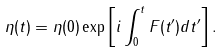Convert formula to latex. <formula><loc_0><loc_0><loc_500><loc_500>\eta ( t ) = \eta ( 0 ) \exp \left [ i \int _ { 0 } ^ { t } F ( t ^ { \prime } ) d t ^ { \prime } \right ] .</formula> 